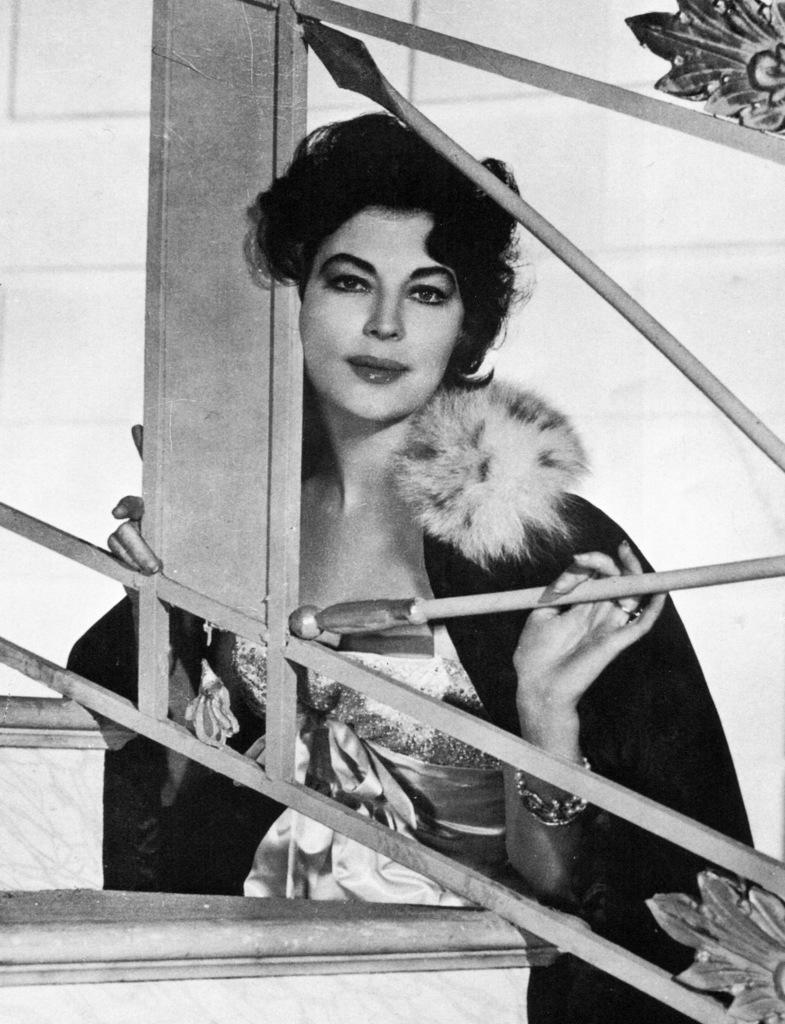What is the color scheme of the image? The image is black and white. Who is present in the image? There is a woman in the image. What is the woman doing in the image? The woman is standing at a fence and holding a pole of the fence in her hand. What can be seen in the background of the image? There is a wall in the background of the image. How does the dirt affect the woman's appearance in the image? There is no dirt present in the image, so it does not affect the woman's appearance. 